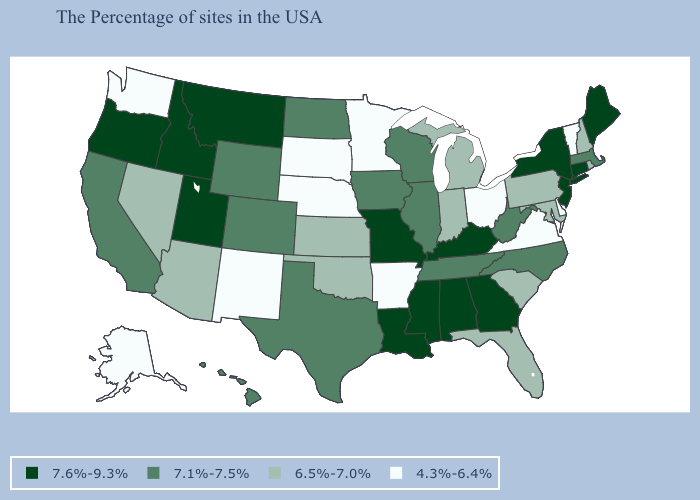Is the legend a continuous bar?
Keep it brief. No. Does Texas have a higher value than Hawaii?
Be succinct. No. What is the value of Nebraska?
Keep it brief. 4.3%-6.4%. What is the value of Nevada?
Concise answer only. 6.5%-7.0%. Name the states that have a value in the range 7.6%-9.3%?
Keep it brief. Maine, Connecticut, New York, New Jersey, Georgia, Kentucky, Alabama, Mississippi, Louisiana, Missouri, Utah, Montana, Idaho, Oregon. What is the value of Mississippi?
Short answer required. 7.6%-9.3%. Does the map have missing data?
Answer briefly. No. Name the states that have a value in the range 6.5%-7.0%?
Write a very short answer. Rhode Island, New Hampshire, Maryland, Pennsylvania, South Carolina, Florida, Michigan, Indiana, Kansas, Oklahoma, Arizona, Nevada. Does the first symbol in the legend represent the smallest category?
Be succinct. No. Does the first symbol in the legend represent the smallest category?
Be succinct. No. Which states hav the highest value in the South?
Answer briefly. Georgia, Kentucky, Alabama, Mississippi, Louisiana. Does Vermont have the highest value in the USA?
Short answer required. No. Name the states that have a value in the range 4.3%-6.4%?
Give a very brief answer. Vermont, Delaware, Virginia, Ohio, Arkansas, Minnesota, Nebraska, South Dakota, New Mexico, Washington, Alaska. Does Nebraska have the lowest value in the USA?
Write a very short answer. Yes. Does Pennsylvania have the lowest value in the Northeast?
Answer briefly. No. 